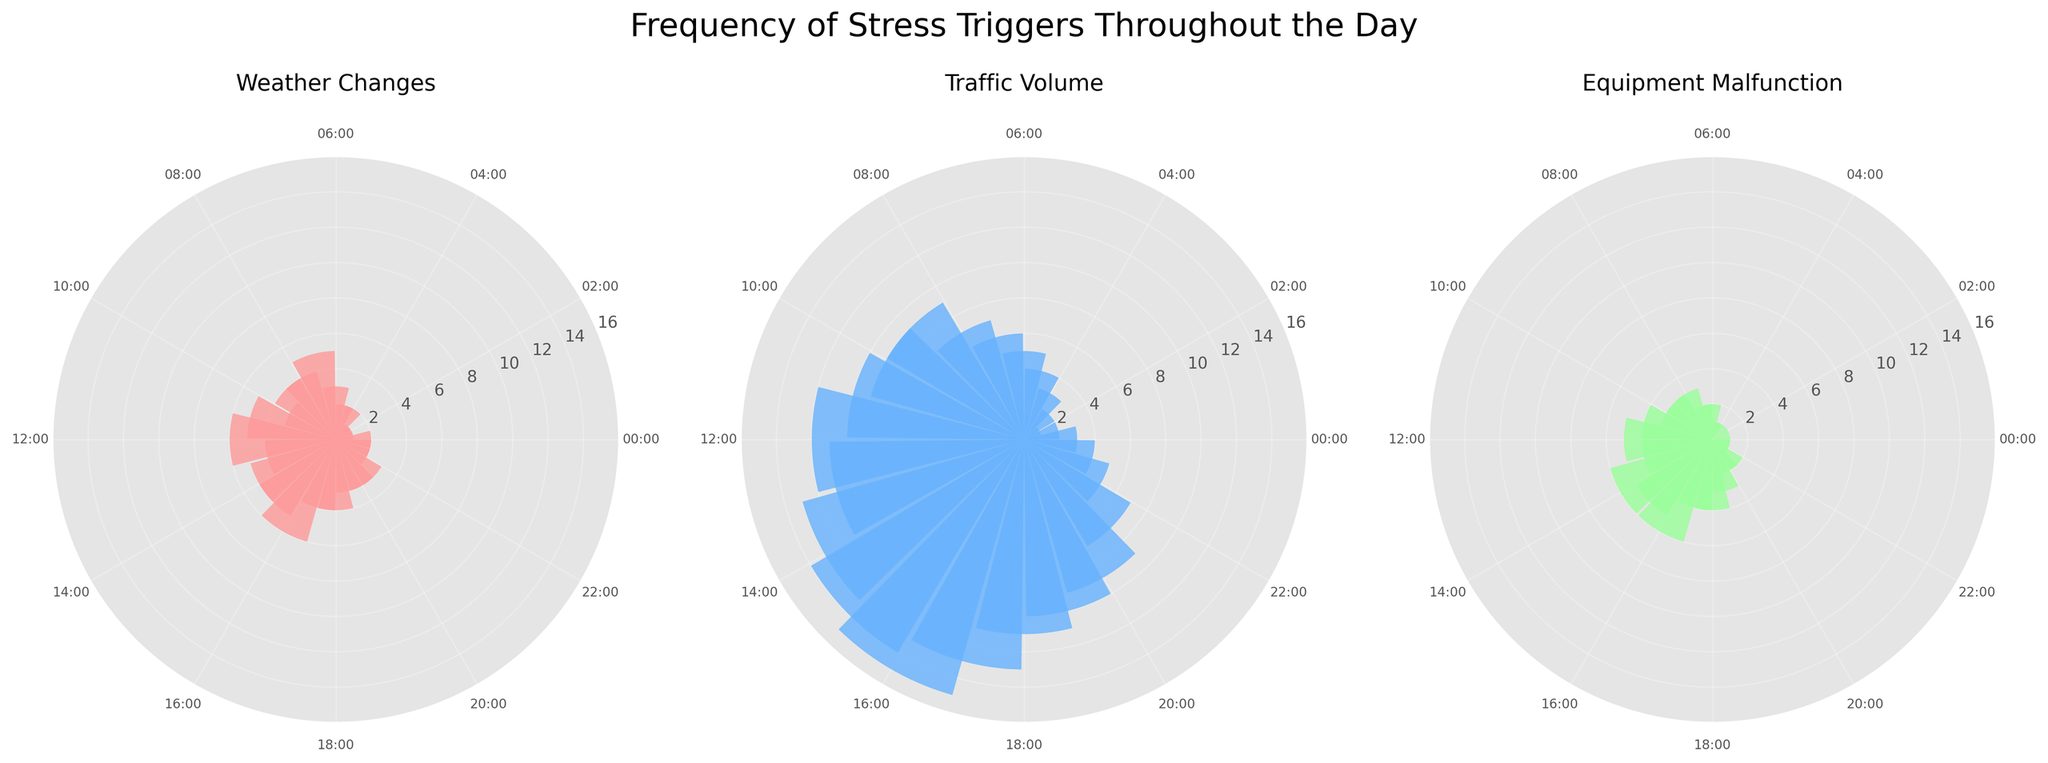How many different stress triggers are displayed in the figure? There are three different subplots in the figure, each representing a different stress trigger. The titles of these subplots indicate the stress triggers: "Weather Changes," "Traffic Volume," and "Equipment Malfunction."
Answer: Three What is the highest frequency of 'Traffic Volume' stress triggers observed? In the 'Traffic Volume' subplot, the highest value on the radial axis is 15. This can be seen by looking at the bar length for the time with the highest frequency.
Answer: 15 During which hour is the frequency of 'Weather Changes' stress triggers the highest? In the 'Weather Changes' subplot, the highest bar reaches 6 units at the 12th and 16th hours. This is identified by locating the longest bars in the subplot.
Answer: 12th and 16th hours What is the combined frequency of 'Equipment Malfunctions' during hours 10, 11, and 12? To find the combined frequency, add the values for hours 10, 11, and 12 in the 'Equipment Malfunctions' subplot: 3 (hour 10) + 4 (hour 11) + 5 (hour 12) = 12.
Answer: 12 Which stress trigger has the lowest frequency at hour 5? By looking at the subplots, at hour 5, 'Equipment Malfunctions' has a frequency of 1, while 'Weather Changes' and 'Traffic Volume' have higher frequencies.
Answer: Equipment Malfunctions Is the frequency of 'Traffic Volume' consistently high throughout the day? By examining the 'Traffic Volume' subplot, it can be seen that the frequency starts low in the early morning, peaks around midday and afternoon, and then decreases towards the evening. It is not consistent but has a clear pattern of higher frequency around midday and afternoon.
Answer: No How does the frequency of 'Weather Changes' at 15:00 compare to 'Equipment Malfunctions' at the same time? At 15:00, the frequency of 'Weather Changes' is 5, while the frequency of 'Equipment Malfunctions' is also 5. This can be verified by looking at the lengths of the bars at that hour in both subplots.
Answer: They are the same What is the average frequency of 'Weather Changes' stress triggers over the observed hours? Sum the frequencies of 'Weather Changes' for each hour: 2+1+1+1+2+2+3+5+4+4+3+5+6+4+5+5+6+4+4+3+3+3+2+2 = 78. There are 24 hours, so the average is 78/24 = 3.25.
Answer: 3.25 Which hours show a declining trend in 'Equipment Malfunctions' after a previous high frequency? After the peak at hour 16 (frequency of 6), the subsequent hours 17 and 18 have lower frequencies (both 4). This shows a declining trend after a high frequency.
Answer: 17 and 18 hours 